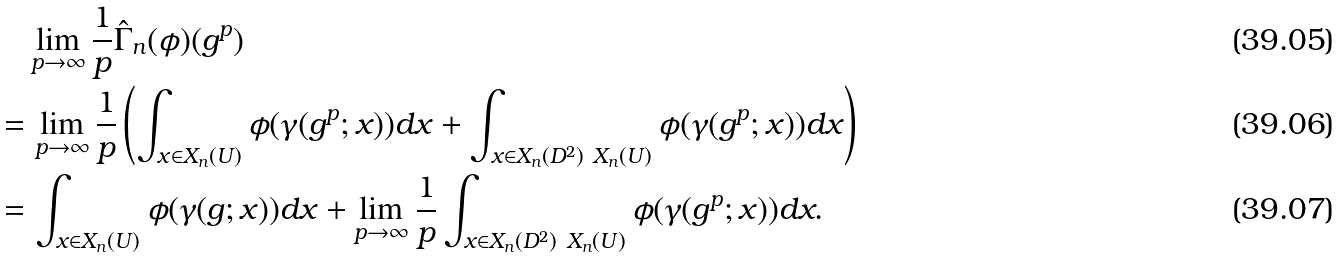Convert formula to latex. <formula><loc_0><loc_0><loc_500><loc_500>& \quad \lim _ { p \to \infty } \frac { 1 } { p } \hat { \Gamma } _ { n } ( \phi ) ( g ^ { p } ) \\ & = \lim _ { p \to \infty } \frac { 1 } { p } \left ( \int _ { x \in X _ { n } ( U ) } \phi ( \gamma ( g ^ { p } ; x ) ) d x + \int _ { x \in X _ { n } ( D ^ { 2 } ) \ X _ { n } ( U ) } \phi ( \gamma ( g ^ { p } ; x ) ) d x \right ) \\ & = \int _ { x \in X _ { n } ( U ) } \phi ( \gamma ( g ; x ) ) d x + \lim _ { p \to \infty } \frac { 1 } { p } \int _ { x \in X _ { n } ( D ^ { 2 } ) \ X _ { n } ( U ) } \phi ( \gamma ( g ^ { p } ; x ) ) d x .</formula> 